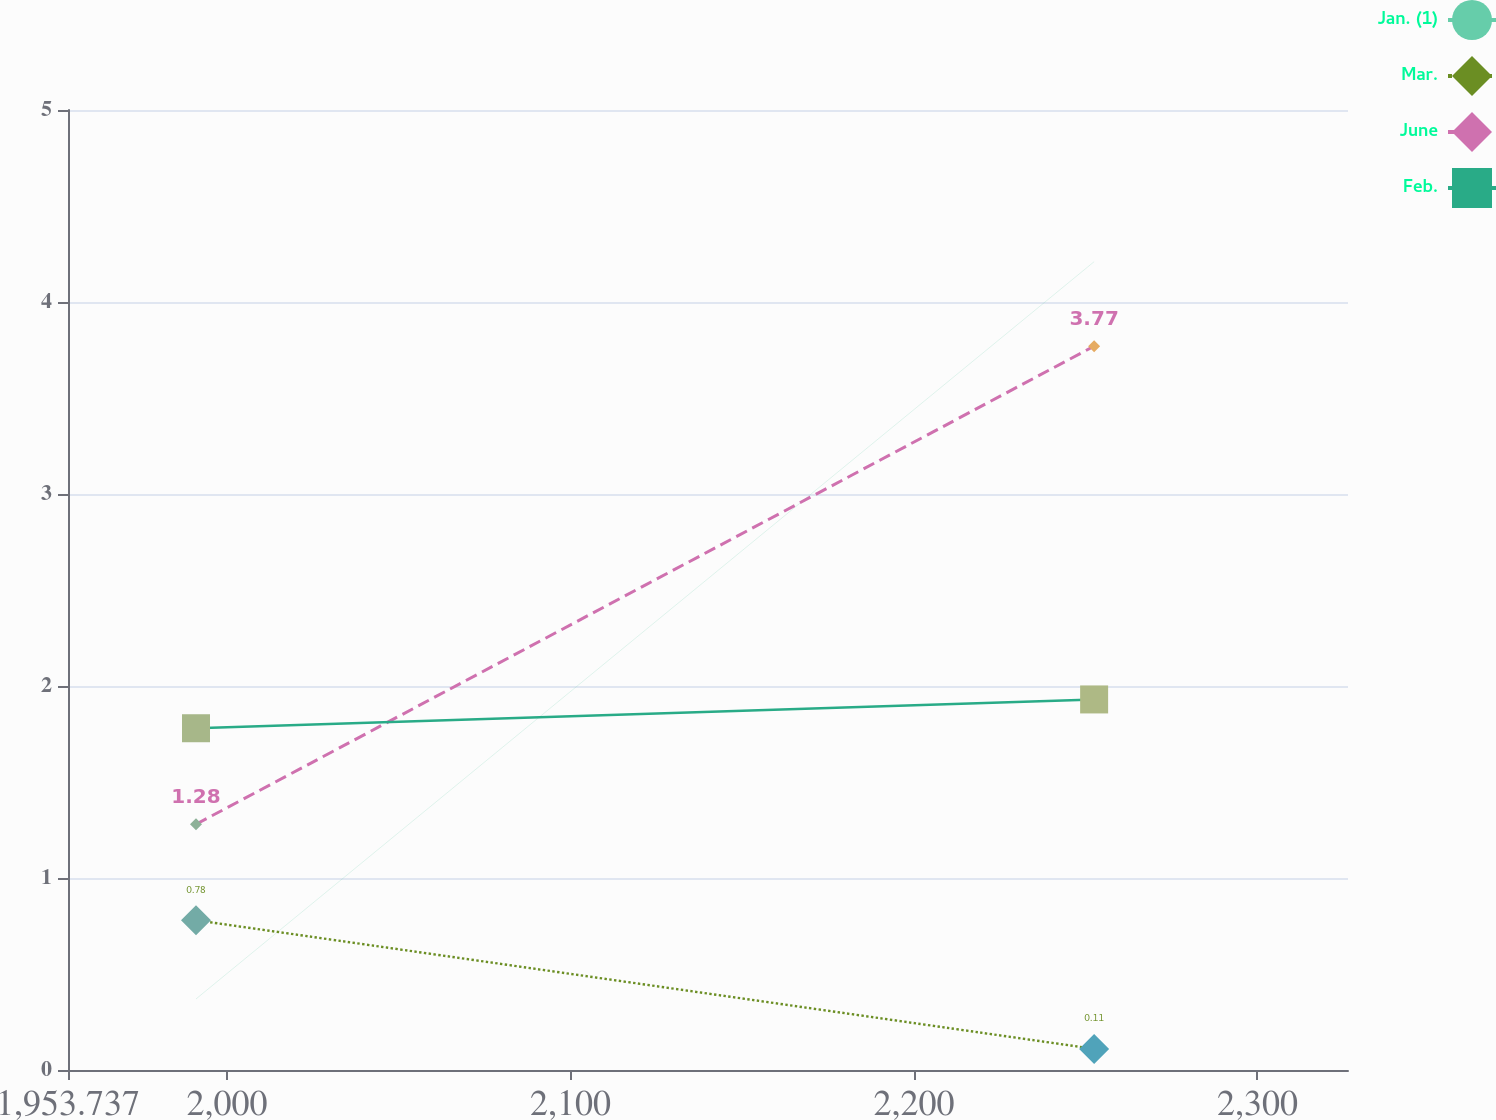Convert chart. <chart><loc_0><loc_0><loc_500><loc_500><line_chart><ecel><fcel>Jan. (1)<fcel>Mar.<fcel>June<fcel>Feb.<nl><fcel>1991<fcel>0.37<fcel>0.78<fcel>1.28<fcel>1.78<nl><fcel>2252.46<fcel>4.21<fcel>0.11<fcel>3.77<fcel>1.93<nl><fcel>2363.63<fcel>1.48<fcel>2.71<fcel>6.05<fcel>2.69<nl></chart> 